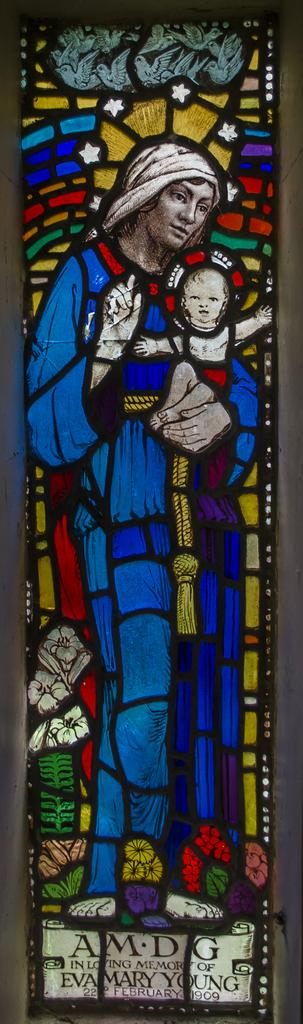What type of artwork is featured in the image? There is a stained glass in the image. Is there any text associated with the artwork? Yes, there is text at the bottom of the image. What type of pets are visible in the image? There are no pets present in the image. What stage of development is depicted in the image? The image does not depict any developmental stages; it features a stained glass with text. 